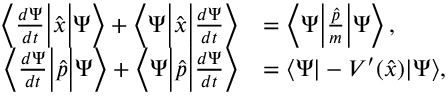Convert formula to latex. <formula><loc_0><loc_0><loc_500><loc_500>{ \begin{array} { r l } { \left \langle { \frac { d \Psi } { d t } } { \left | } { \hat { x } } { \right | } \Psi \right \rangle + \left \langle \Psi { \left | } { \hat { x } } { \right | } { \frac { d \Psi } { d t } } \right \rangle } & { = \left \langle \Psi { \left | } { \frac { \hat { p } } { m } } { \right | } \Psi \right \rangle , } \\ { \left \langle { \frac { d \Psi } { d t } } { \left | } { \hat { p } } { \right | } \Psi \right \rangle + \left \langle \Psi { \left | } { \hat { p } } { \right | } { \frac { d \Psi } { d t } } \right \rangle } & { = \langle \Psi | - V ^ { \prime } ( { \hat { x } } ) | \Psi \rangle , } \end{array} }</formula> 